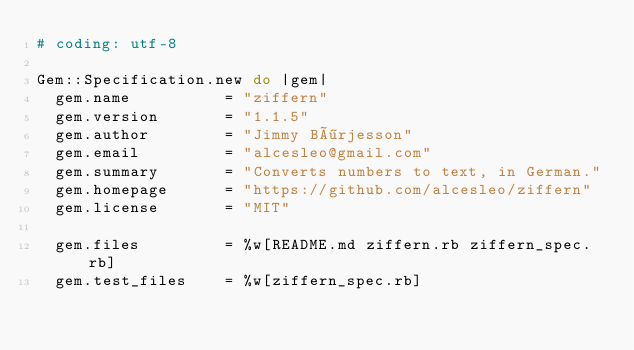Convert code to text. <code><loc_0><loc_0><loc_500><loc_500><_Ruby_># coding: utf-8

Gem::Specification.new do |gem|
  gem.name          = "ziffern"
  gem.version       = "1.1.5"
  gem.author        = "Jimmy Börjesson"
  gem.email         = "alcesleo@gmail.com"
  gem.summary       = "Converts numbers to text, in German."
  gem.homepage      = "https://github.com/alcesleo/ziffern"
  gem.license       = "MIT"

  gem.files         = %w[README.md ziffern.rb ziffern_spec.rb]
  gem.test_files    = %w[ziffern_spec.rb]</code> 